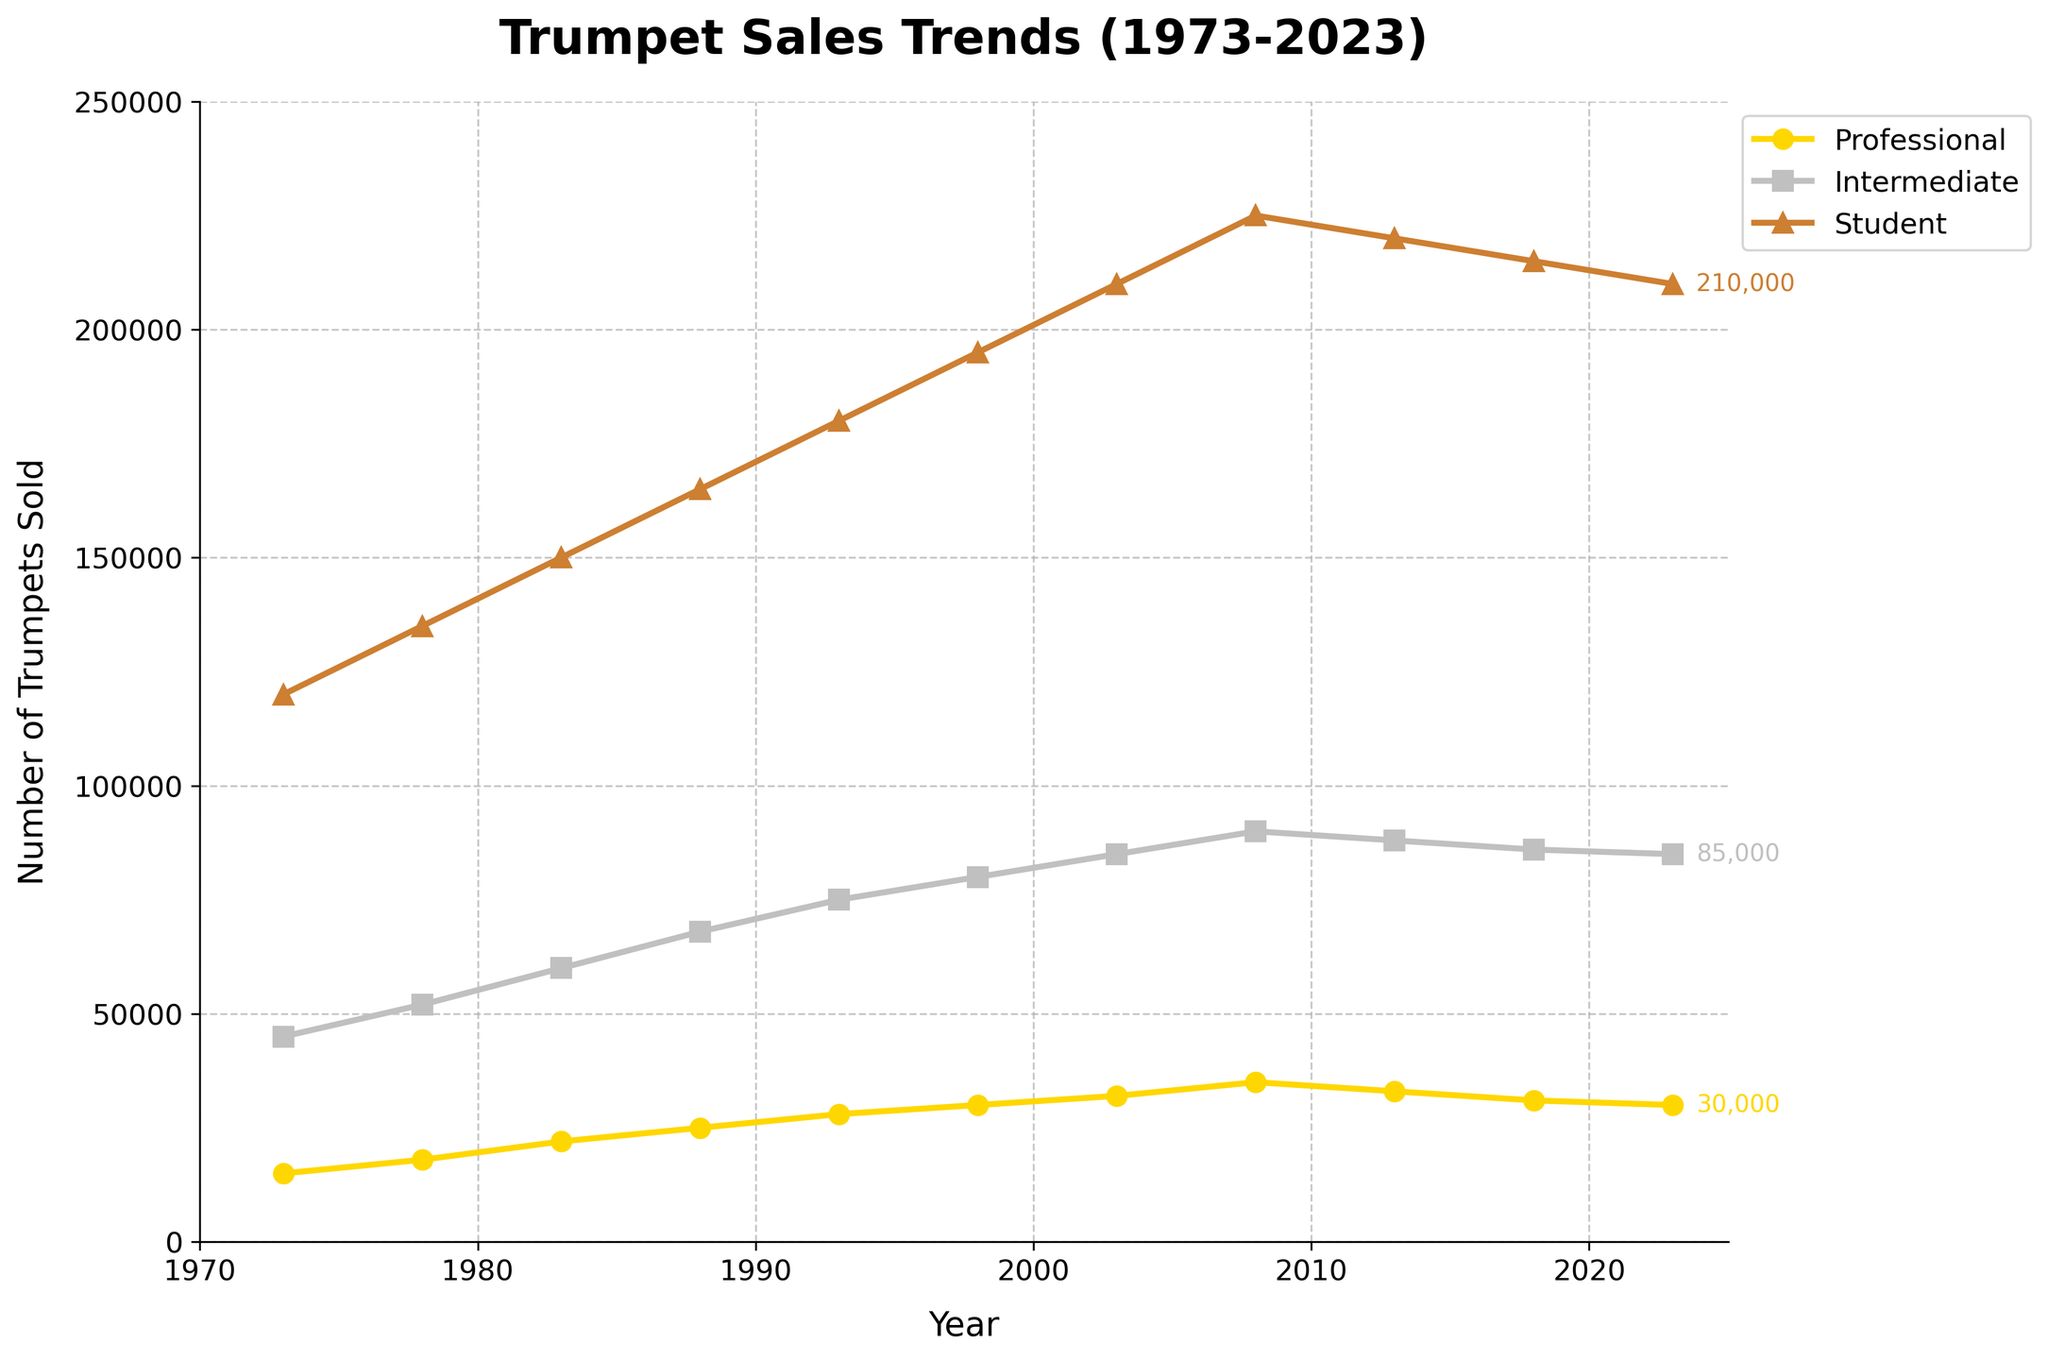What's the overall trend for professional trumpet sales from 1973 to 2023? Professional trumpet sales increased steadily from 1973 (15,000) to 2008 (35,000). After reaching a peak, the sales decreased, returning to 30,000 in 2023.
Answer: Increasing to 2008, then decreasing How does the sales trend of student trumpets compare to intermediate trumpets over the years? Both student and intermediate trumpet sales increased steadily from 1973 to 2008. After 2008, they exhibited a slight decline, but student trumpet sales are significantly higher than intermediate throughout the years.
Answer: Both increased till 2008, then slightly declined; student sales much higher In which year did professional trumpet sales peak, and what was the sales figure? From the chart, professional trumpet sales reached their highest value in 2008, at 35,000 units.
Answer: 2008, 35,000 What is the difference in sales figures between student and intermediate trumpets in 2018? In 2018, student trumpet sales were 215,000, and intermediate trumpet sales were 86,000. The difference is calculated as 215,000 - 86,000 = 129,000.
Answer: 129,000 Compare the trend in professional and student trumpet sales between 2013 and 2023. Which model saw a greater decline? From 2013 to 2023, professional trumpet sales declined from 33,000 to 30,000, a decrease of 3,000 units. Student trumpet sales fell from 220,000 to 210,000, a decrease of 10,000 units. Hence, student models saw a greater decline.
Answer: Student models, 10,000 Which trumpet model had the highest sales in 1983? In 1983, the sales figures were: Professional 22,000, Intermediate 60,000, and Student 150,000. Student models had the highest sales.
Answer: Student Calculate the average sales of student trumpets over the 50 years. Sum of student trumpet sales over the years is 2,115,000. There are 11 data points. Average sales = 2,115,000 / 11 ≈ 192,273.
Answer: 192,273 In which year is the smallest difference in sales between professional and intermediate trumpet models, and what is the value? The smallest difference occurred in 2023, where professional sales were 30,000 and intermediate were 85,000. The difference is 55,000.
Answer: 2023, 55,000 What color represents intermediate trumpet sales in the chart? The intermediate trumpet sales are marked by a silver color in the chart.
Answer: Silver How did the sales of intermediate trumpet models change between 1998 and 2023 compared to professional models? Intermediate trumpet sales increased from 80,000 in 1998 to a peak of 90,000 in 2008, then declined to 85,000 in 2023. Professional models rose from 30,000 in 1998 to 35,00 in 2008 and dropped to 30,000 in 2023. Intermediate sales had a net increase, while professional models remained the same.
Answer: Intermediate increased net, Professional stayed same 